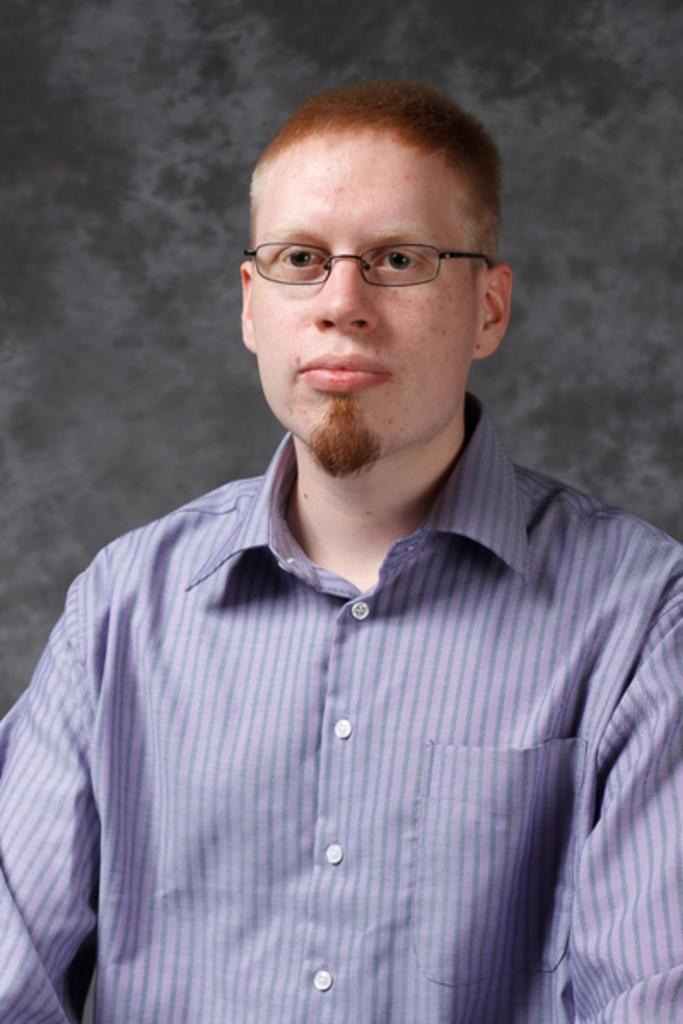Who is present in the image? There is a man in the image. What is the man wearing in the image? The man is wearing a blue shirt in the image. What is the color of the background in the image? The background in the image is black. Are there any fairies visible in the image? No, there are no fairies present in the image. What type of flock can be seen flying in the image? There is no flock visible in the image; it features a man in a blue shirt against a black background. 